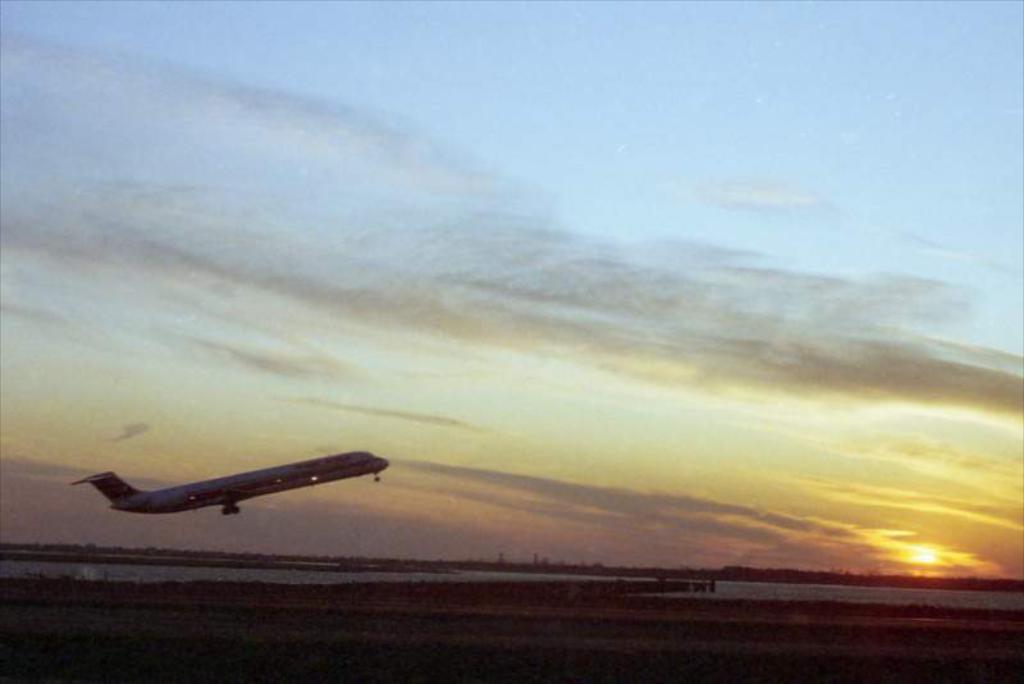What is happening in the image involving a vehicle? There is a flight taking off in the image. What natural phenomenon is visible in the image? There is a sunset visible in the image. What body of water is present in the image? There is a river in the image. What part of the natural environment is visible in the image? The sky is visible in the image. What type of crayon is being used to draw the flight in the image? There is no crayon present in the image; it is a photograph or illustration of a flight taking off. Can you tell me how many cameras are visible in the image? There are no cameras visible in the image. 